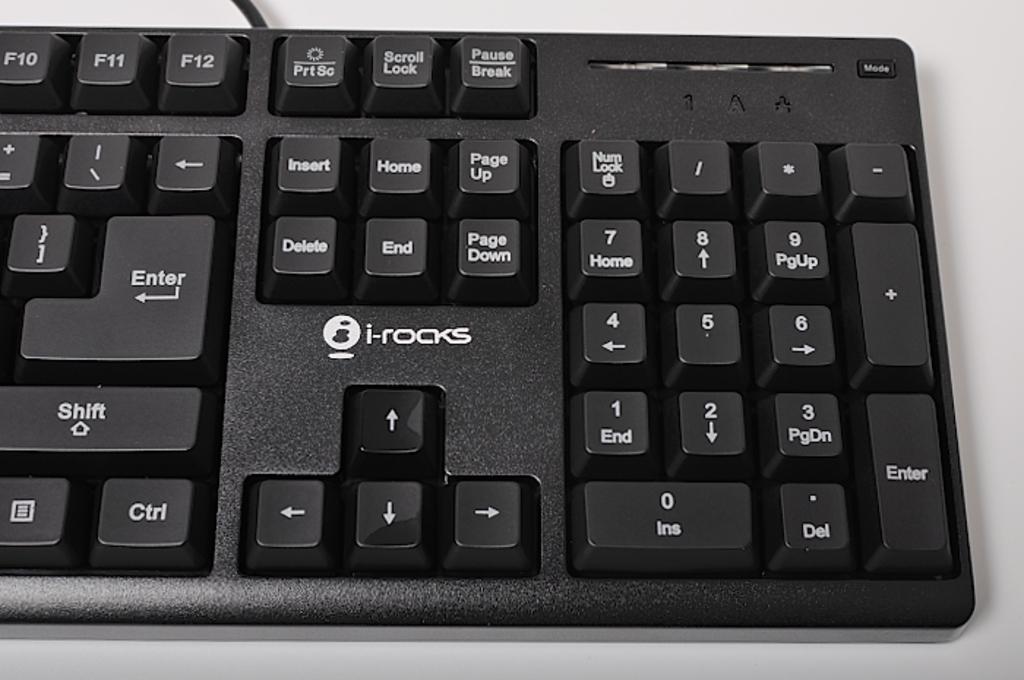What brand is the keyboard?
Provide a short and direct response. I-rocks. I rocks keyboard?
Your response must be concise. Yes. 